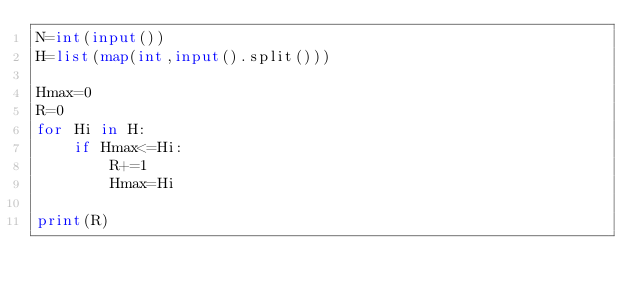Convert code to text. <code><loc_0><loc_0><loc_500><loc_500><_Python_>N=int(input())
H=list(map(int,input().split()))

Hmax=0
R=0
for Hi in H:
    if Hmax<=Hi:
        R+=1
        Hmax=Hi

print(R)</code> 